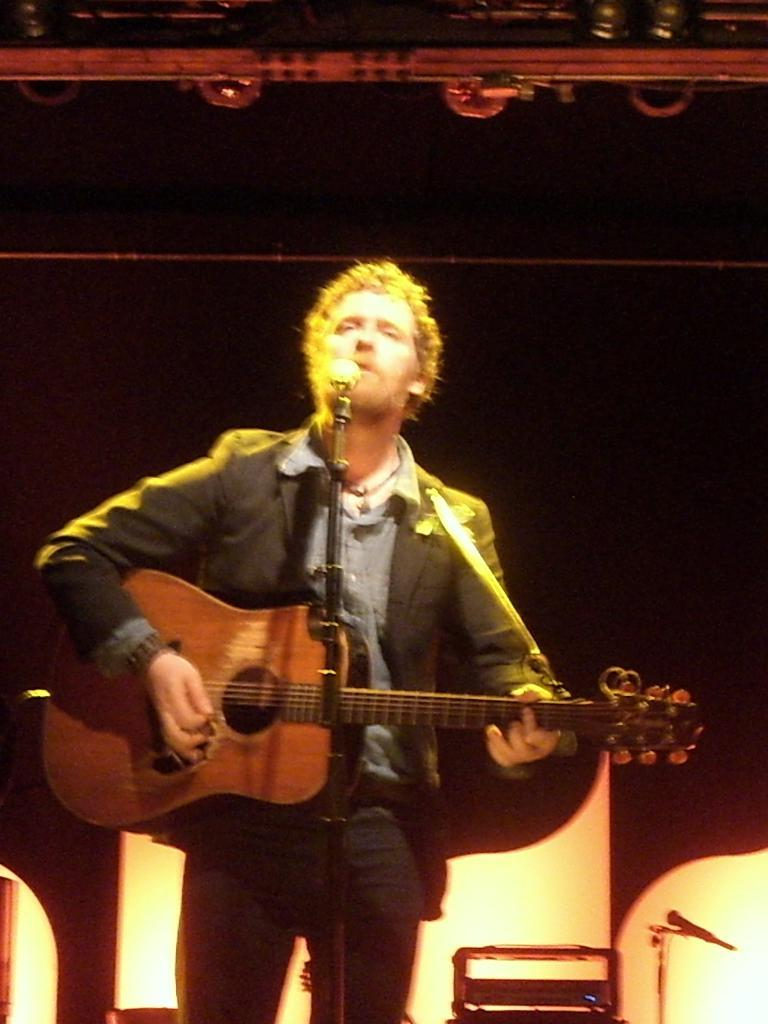What is the color of the background in the image? The background of the image is dark. What is the man in the image doing? The man is playing a guitar and singing. What object is the man using to amplify his voice? There is a microphone in the image that the man is using. What type of jelly can be seen on the ground in the image? There is no jelly present in the image, and the ground is not visible. What flavor of soda is the man drinking while playing the guitar? There is no soda present in the image, and the man is not shown drinking anything. 